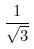<formula> <loc_0><loc_0><loc_500><loc_500>\frac { 1 } { \sqrt { 3 } }</formula> 